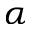<formula> <loc_0><loc_0><loc_500><loc_500>\alpha</formula> 